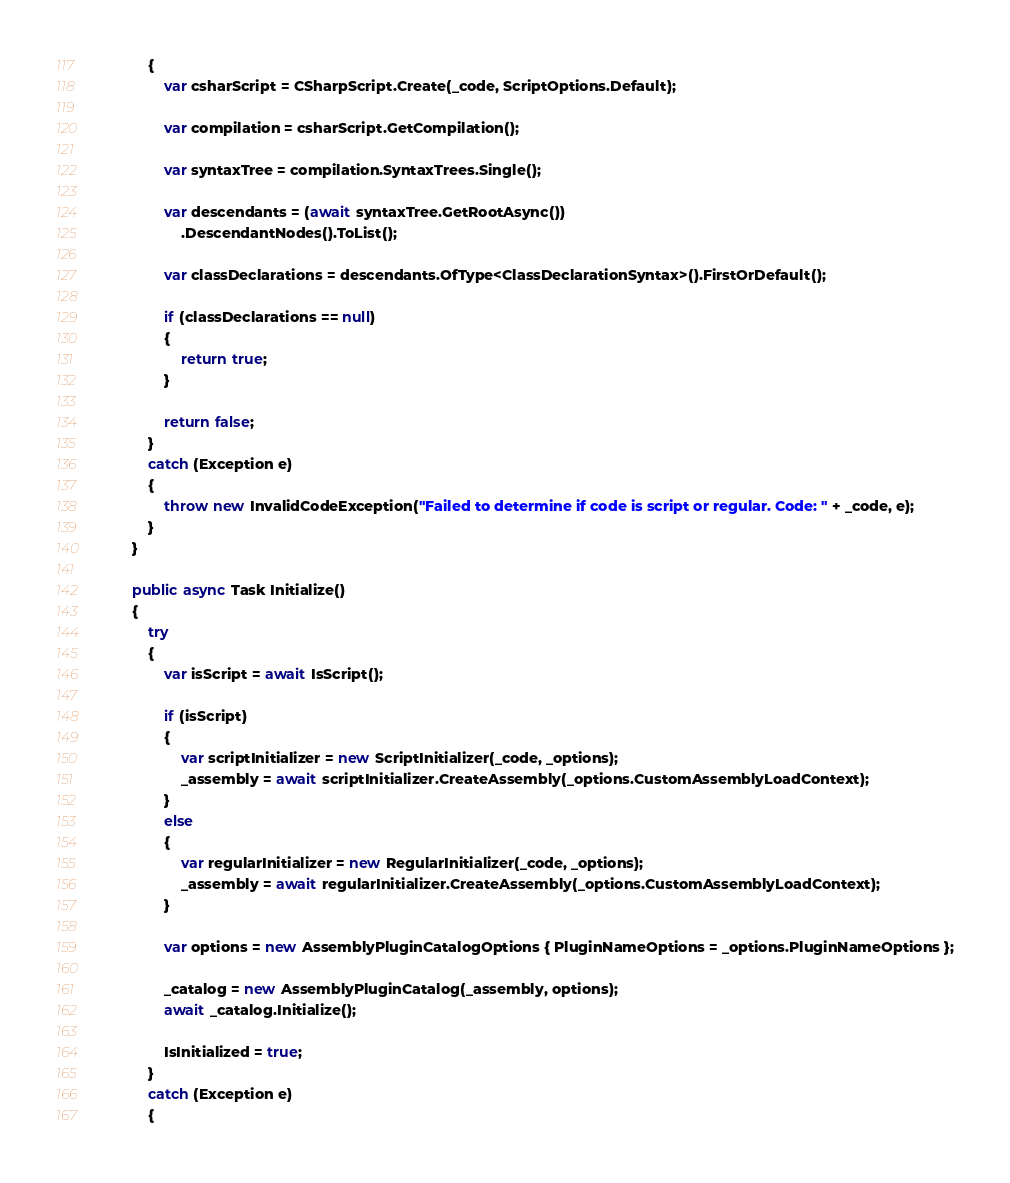Convert code to text. <code><loc_0><loc_0><loc_500><loc_500><_C#_>            {
                var csharScript = CSharpScript.Create(_code, ScriptOptions.Default);

                var compilation = csharScript.GetCompilation();

                var syntaxTree = compilation.SyntaxTrees.Single();

                var descendants = (await syntaxTree.GetRootAsync())
                    .DescendantNodes().ToList();

                var classDeclarations = descendants.OfType<ClassDeclarationSyntax>().FirstOrDefault();

                if (classDeclarations == null)
                {
                    return true;
                }

                return false;
            }
            catch (Exception e)
            {
                throw new InvalidCodeException("Failed to determine if code is script or regular. Code: " + _code, e);
            }
        }

        public async Task Initialize()
        {
            try
            {
                var isScript = await IsScript();

                if (isScript)
                {
                    var scriptInitializer = new ScriptInitializer(_code, _options);
                    _assembly = await scriptInitializer.CreateAssembly(_options.CustomAssemblyLoadContext);
                }
                else
                {
                    var regularInitializer = new RegularInitializer(_code, _options);
                    _assembly = await regularInitializer.CreateAssembly(_options.CustomAssemblyLoadContext);
                }

                var options = new AssemblyPluginCatalogOptions { PluginNameOptions = _options.PluginNameOptions };

                _catalog = new AssemblyPluginCatalog(_assembly, options);
                await _catalog.Initialize();

                IsInitialized = true;
            }
            catch (Exception e)
            {</code> 